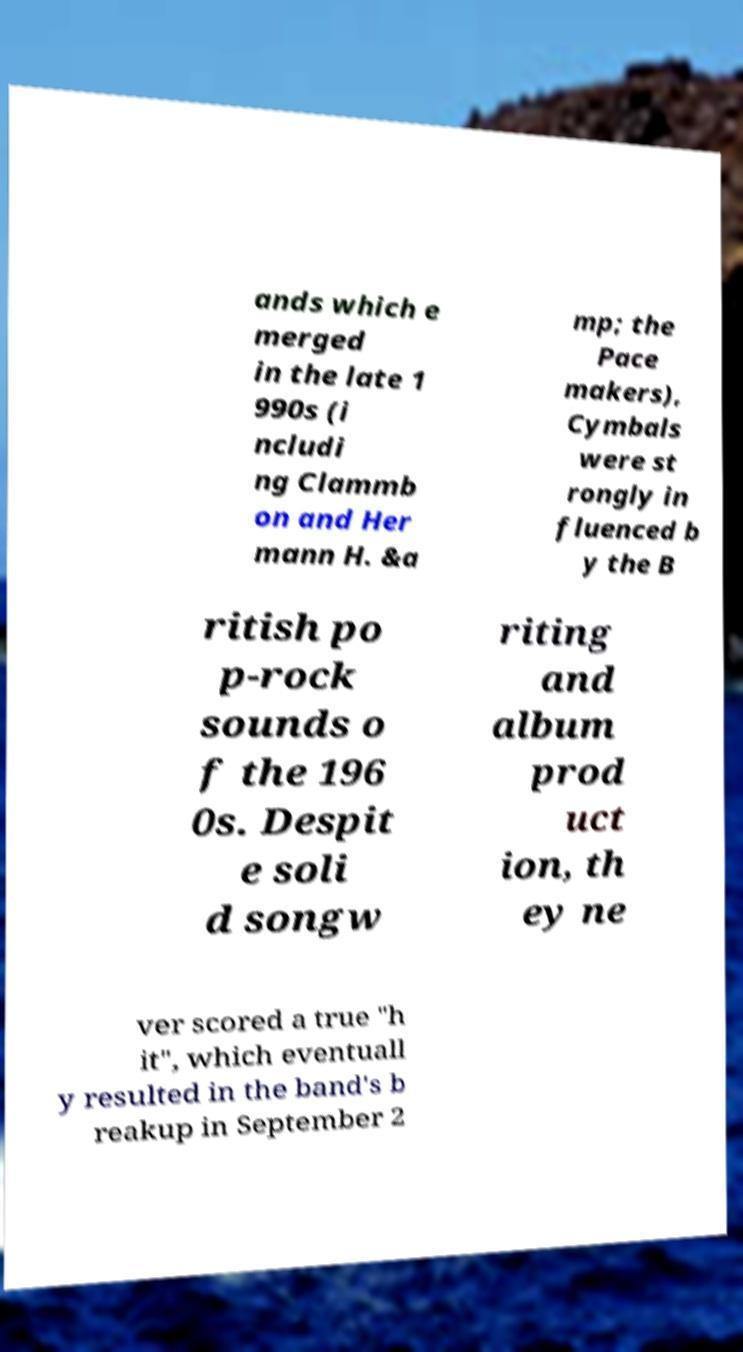Could you extract and type out the text from this image? ands which e merged in the late 1 990s (i ncludi ng Clammb on and Her mann H. &a mp; the Pace makers), Cymbals were st rongly in fluenced b y the B ritish po p-rock sounds o f the 196 0s. Despit e soli d songw riting and album prod uct ion, th ey ne ver scored a true "h it", which eventuall y resulted in the band's b reakup in September 2 